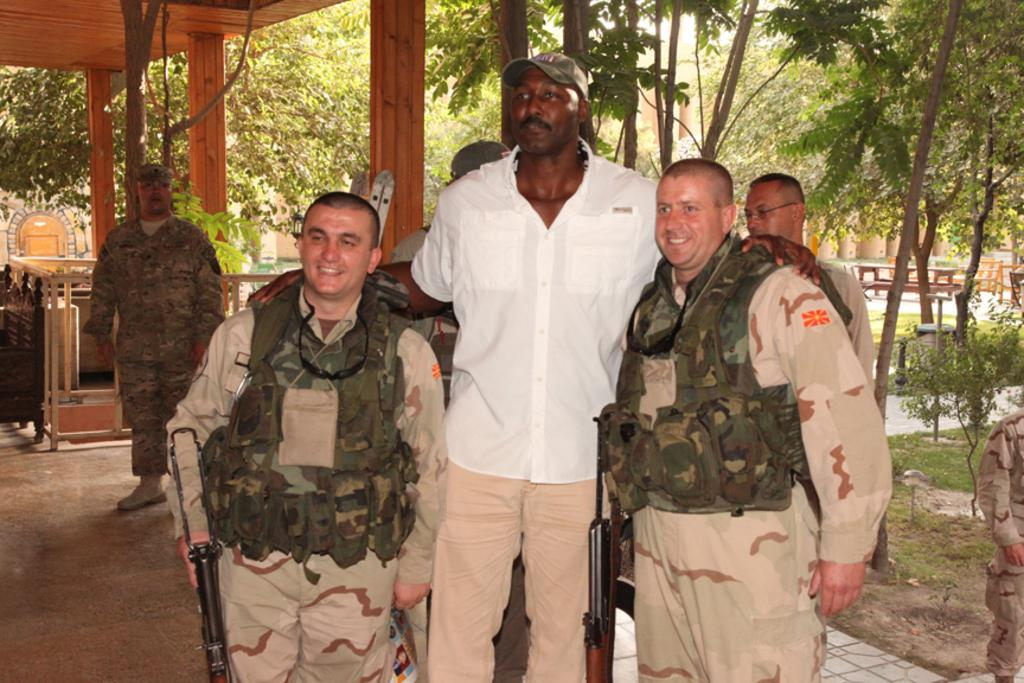What can be seen in the image? There are men standing in the image, along with benches, plants, electric lights, trees, buildings, and the sky. Where are the men standing? The men are standing on the floor in the image. What type of objects are present in the image for seating? There are benches in the image for seating. What can be seen in the background of the image? There are trees and buildings visible in the background of the image. What is the source of illumination in the image? Electric lights are visible in the image. How does the coach affect the men in the image? There is no coach present in the image, so it cannot affect the men. What color is the nose of the man on the left? There is no mention of a nose or a man on the left in the provided facts, so it cannot be determined. 